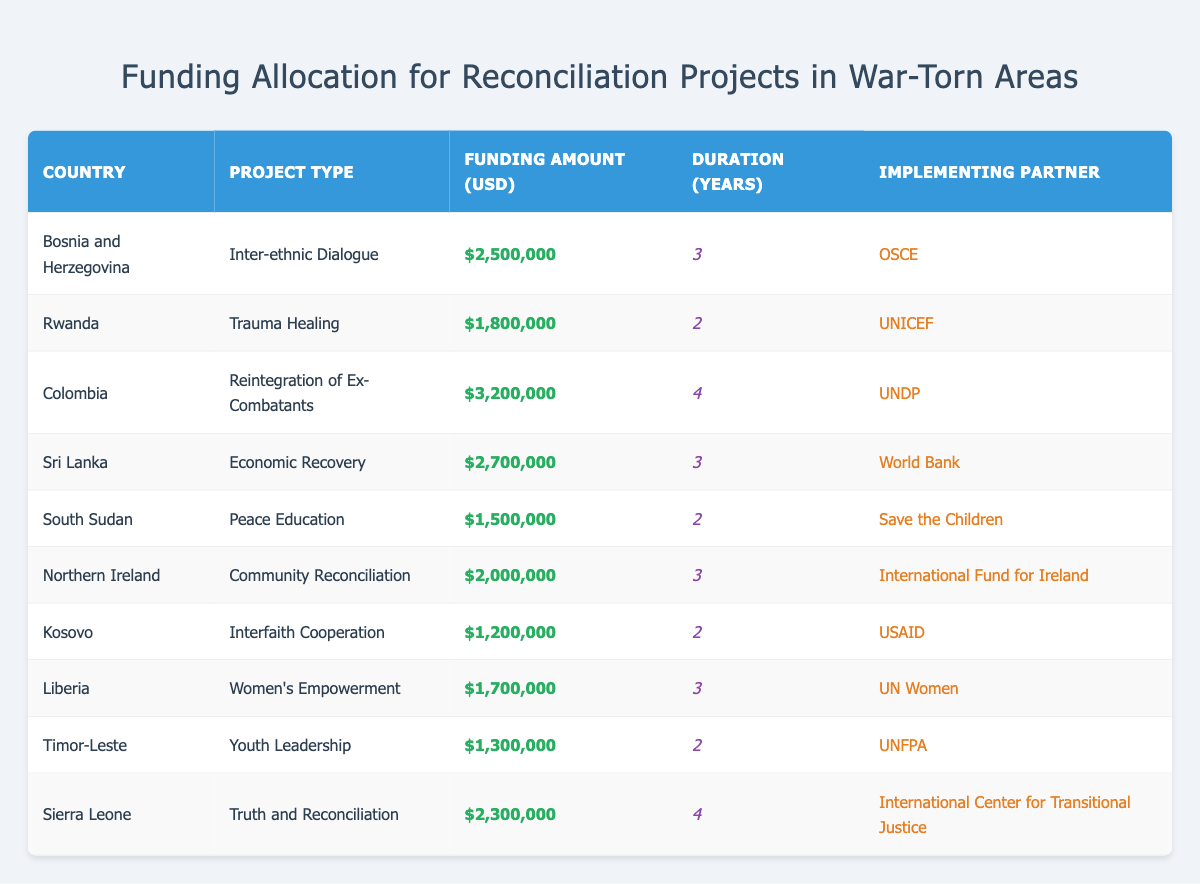What is the total funding allocated for reconciliation projects in South Sudan? The table indicates that the funding amount for South Sudan is $1,500,000.
Answer: 1,500,000 Which country received the highest funding for reconciliation projects? Colombia received the highest funding of $3,200,000 for the Reintegration of Ex-Combatants project.
Answer: Colombia How many countries have projects with a duration of 2 years? Upon examining the table, the countries with a duration of 2 years are Rwanda, South Sudan, Kosovo, and Timor-Leste, totaling four countries.
Answer: 4 What is the average funding amount across all projects? To find the average, we sum all funding amounts: $2,500,000 + $1,800,000 + $3,200,000 + $2,700,000 + $1,500,000 + $2,000,000 + $1,200,000 + $1,700,000 + $1,300,000 + $2,300,000 = $21,200,000. Then, we divide by the number of projects, which is 10: $21,200,000 / 10 = $2,120,000.
Answer: 2,120,000 Is there a reconciliation project focused on economic recovery in any country? Yes, Sri Lanka has a project focused on Economic Recovery with funding of $2,700,000.
Answer: Yes Which implementing partner is associated with the "Truth and Reconciliation" project? The table lists the International Center for Transitional Justice as the implementing partner for the Truth and Reconciliation project in Sierra Leone.
Answer: International Center for Transitional Justice What is the difference between the funding amounts for the highest and lowest funded projects? From the table, the highest funding is $3,200,000 for Colombia, and the lowest is $1,200,000 for Kosovo. The difference is $3,200,000 - $1,200,000 = $2,000,000.
Answer: 2,000,000 Which project type has the second highest funding amount? By reviewing the funding amounts, the Reintegration of Ex-Combatants in Colombia has $3,200,000, and the Economic Recovery in Sri Lanka follows with $2,700,000. Thus, the second highest project type is Economic Recovery.
Answer: Economic Recovery How many projects are funded by UN agencies? The projects funded by UN agencies are Trauma Healing by UNICEF, Women's Empowerment by UN Women, and Youth Leadership by UNFPA, making a total of three projects.
Answer: 3 What percentage of the total funding is allocated to projects in Colombia and Sierra Leone combined? The total funding for Colombia is $3,200,000 and for Sierra Leone is $2,300,000. The combined funding is $3,200,000 + $2,300,000 = $5,500,000. To find the percentage of the total funding, we first calculate the total funding of all projects, which is $21,200,000. So, ($5,500,000 / $21,200,000) * 100 = 25.92%.
Answer: Approximately 25.92% 